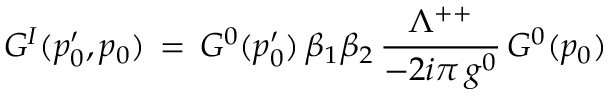Convert formula to latex. <formula><loc_0><loc_0><loc_500><loc_500>G ^ { I } ( p _ { 0 } ^ { \prime } , p _ { 0 } ) \, = \, G ^ { 0 } ( p _ { 0 } ^ { \prime } ) \, \beta _ { 1 } \beta _ { 2 } \, { \frac { \Lambda ^ { + + } } { - 2 i \pi \, g ^ { 0 } } } \, G ^ { 0 } ( p _ { 0 } )</formula> 